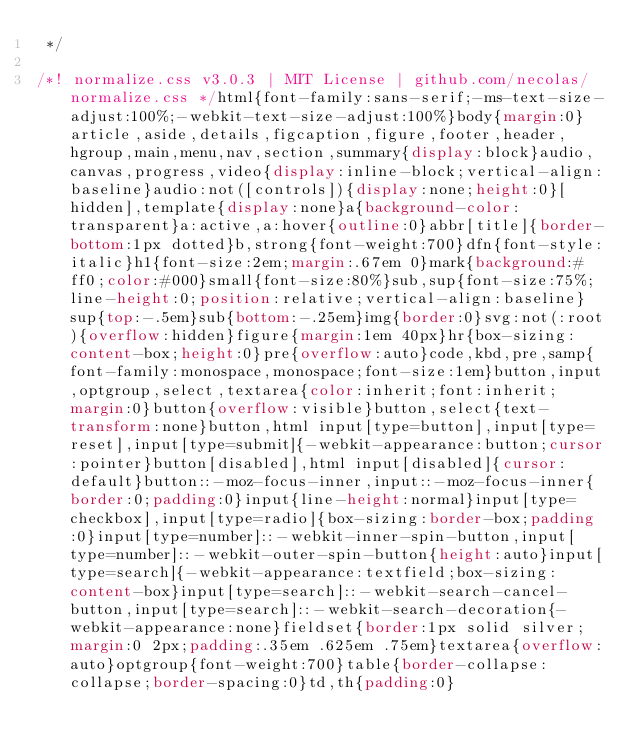<code> <loc_0><loc_0><loc_500><loc_500><_CSS_> */

/*! normalize.css v3.0.3 | MIT License | github.com/necolas/normalize.css */html{font-family:sans-serif;-ms-text-size-adjust:100%;-webkit-text-size-adjust:100%}body{margin:0}article,aside,details,figcaption,figure,footer,header,hgroup,main,menu,nav,section,summary{display:block}audio,canvas,progress,video{display:inline-block;vertical-align:baseline}audio:not([controls]){display:none;height:0}[hidden],template{display:none}a{background-color:transparent}a:active,a:hover{outline:0}abbr[title]{border-bottom:1px dotted}b,strong{font-weight:700}dfn{font-style:italic}h1{font-size:2em;margin:.67em 0}mark{background:#ff0;color:#000}small{font-size:80%}sub,sup{font-size:75%;line-height:0;position:relative;vertical-align:baseline}sup{top:-.5em}sub{bottom:-.25em}img{border:0}svg:not(:root){overflow:hidden}figure{margin:1em 40px}hr{box-sizing:content-box;height:0}pre{overflow:auto}code,kbd,pre,samp{font-family:monospace,monospace;font-size:1em}button,input,optgroup,select,textarea{color:inherit;font:inherit;margin:0}button{overflow:visible}button,select{text-transform:none}button,html input[type=button],input[type=reset],input[type=submit]{-webkit-appearance:button;cursor:pointer}button[disabled],html input[disabled]{cursor:default}button::-moz-focus-inner,input::-moz-focus-inner{border:0;padding:0}input{line-height:normal}input[type=checkbox],input[type=radio]{box-sizing:border-box;padding:0}input[type=number]::-webkit-inner-spin-button,input[type=number]::-webkit-outer-spin-button{height:auto}input[type=search]{-webkit-appearance:textfield;box-sizing:content-box}input[type=search]::-webkit-search-cancel-button,input[type=search]::-webkit-search-decoration{-webkit-appearance:none}fieldset{border:1px solid silver;margin:0 2px;padding:.35em .625em .75em}textarea{overflow:auto}optgroup{font-weight:700}table{border-collapse:collapse;border-spacing:0}td,th{padding:0}
</code> 